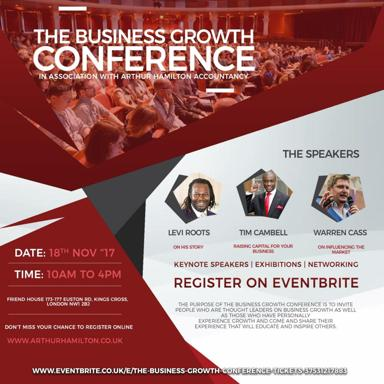What is the date and time for the event? The Business Growth Conference is scheduled for the 18th of November, running from 10 AM to 4 PM. It provides a full day packed with insightful presentations and networking opportunities. 